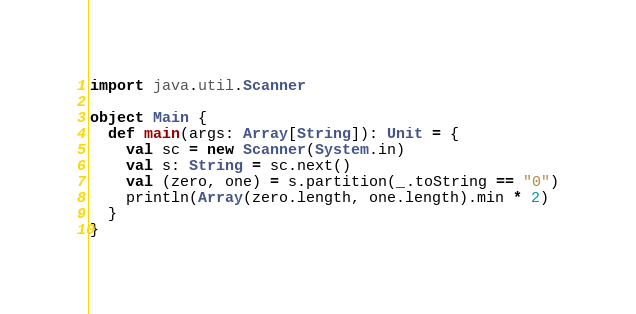<code> <loc_0><loc_0><loc_500><loc_500><_Scala_>import java.util.Scanner

object Main {
  def main(args: Array[String]): Unit = {
    val sc = new Scanner(System.in)
    val s: String = sc.next()
    val (zero, one) = s.partition(_.toString == "0")
    println(Array(zero.length, one.length).min * 2)
  }
}
</code> 